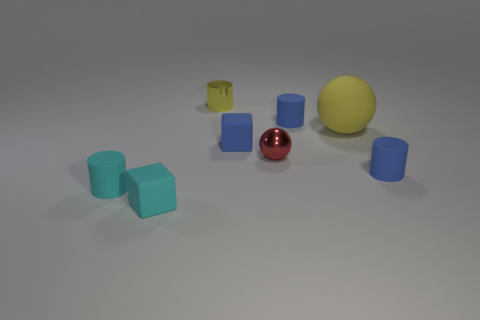There is a large object behind the red thing; is its shape the same as the small red object?
Offer a terse response. Yes. Are there any small cyan things of the same shape as the big thing?
Offer a terse response. No. What number of objects are either objects behind the large yellow object or shiny objects?
Your response must be concise. 3. Is the number of gray spheres greater than the number of small shiny cylinders?
Offer a very short reply. No. Is there a red shiny thing that has the same size as the blue cube?
Your answer should be compact. Yes. What number of objects are matte cylinders that are to the right of the big sphere or matte objects left of the yellow shiny object?
Offer a terse response. 3. The shiny thing that is in front of the blue cylinder that is behind the yellow ball is what color?
Your answer should be very brief. Red. What color is the thing that is the same material as the small ball?
Give a very brief answer. Yellow. What number of metal objects have the same color as the big matte ball?
Your answer should be very brief. 1. What number of objects are either small blue cylinders or tiny cyan things?
Provide a short and direct response. 4. 